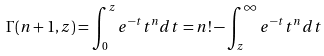<formula> <loc_0><loc_0><loc_500><loc_500>\Gamma ( n + 1 , z ) = \int _ { 0 } ^ { z } e ^ { - t } t ^ { n } d t = n ! - \int _ { z } ^ { \infty } e ^ { - t } t ^ { n } d t</formula> 